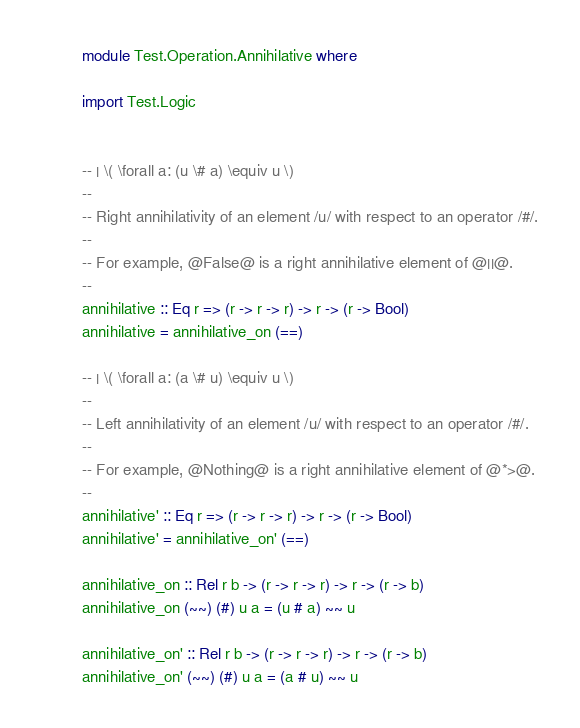Convert code to text. <code><loc_0><loc_0><loc_500><loc_500><_Haskell_>module Test.Operation.Annihilative where

import Test.Logic


-- | \( \forall a: (u \# a) \equiv u \)
--
-- Right annihilativity of an element /u/ with respect to an operator /#/.
--
-- For example, @False@ is a right annihilative element of @||@.
--
annihilative :: Eq r => (r -> r -> r) -> r -> (r -> Bool)
annihilative = annihilative_on (==)

-- | \( \forall a: (a \# u) \equiv u \)
--
-- Left annihilativity of an element /u/ with respect to an operator /#/.
--
-- For example, @Nothing@ is a right annihilative element of @*>@.
--
annihilative' :: Eq r => (r -> r -> r) -> r -> (r -> Bool)
annihilative' = annihilative_on' (==)

annihilative_on :: Rel r b -> (r -> r -> r) -> r -> (r -> b)
annihilative_on (~~) (#) u a = (u # a) ~~ u

annihilative_on' :: Rel r b -> (r -> r -> r) -> r -> (r -> b)
annihilative_on' (~~) (#) u a = (a # u) ~~ u
</code> 